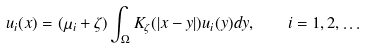<formula> <loc_0><loc_0><loc_500><loc_500>u _ { i } ( x ) = ( \mu _ { i } + \zeta ) \int _ { \Omega } K _ { \zeta } ( | x - y | ) u _ { i } ( y ) d y , \quad i = 1 , 2 , \dots</formula> 